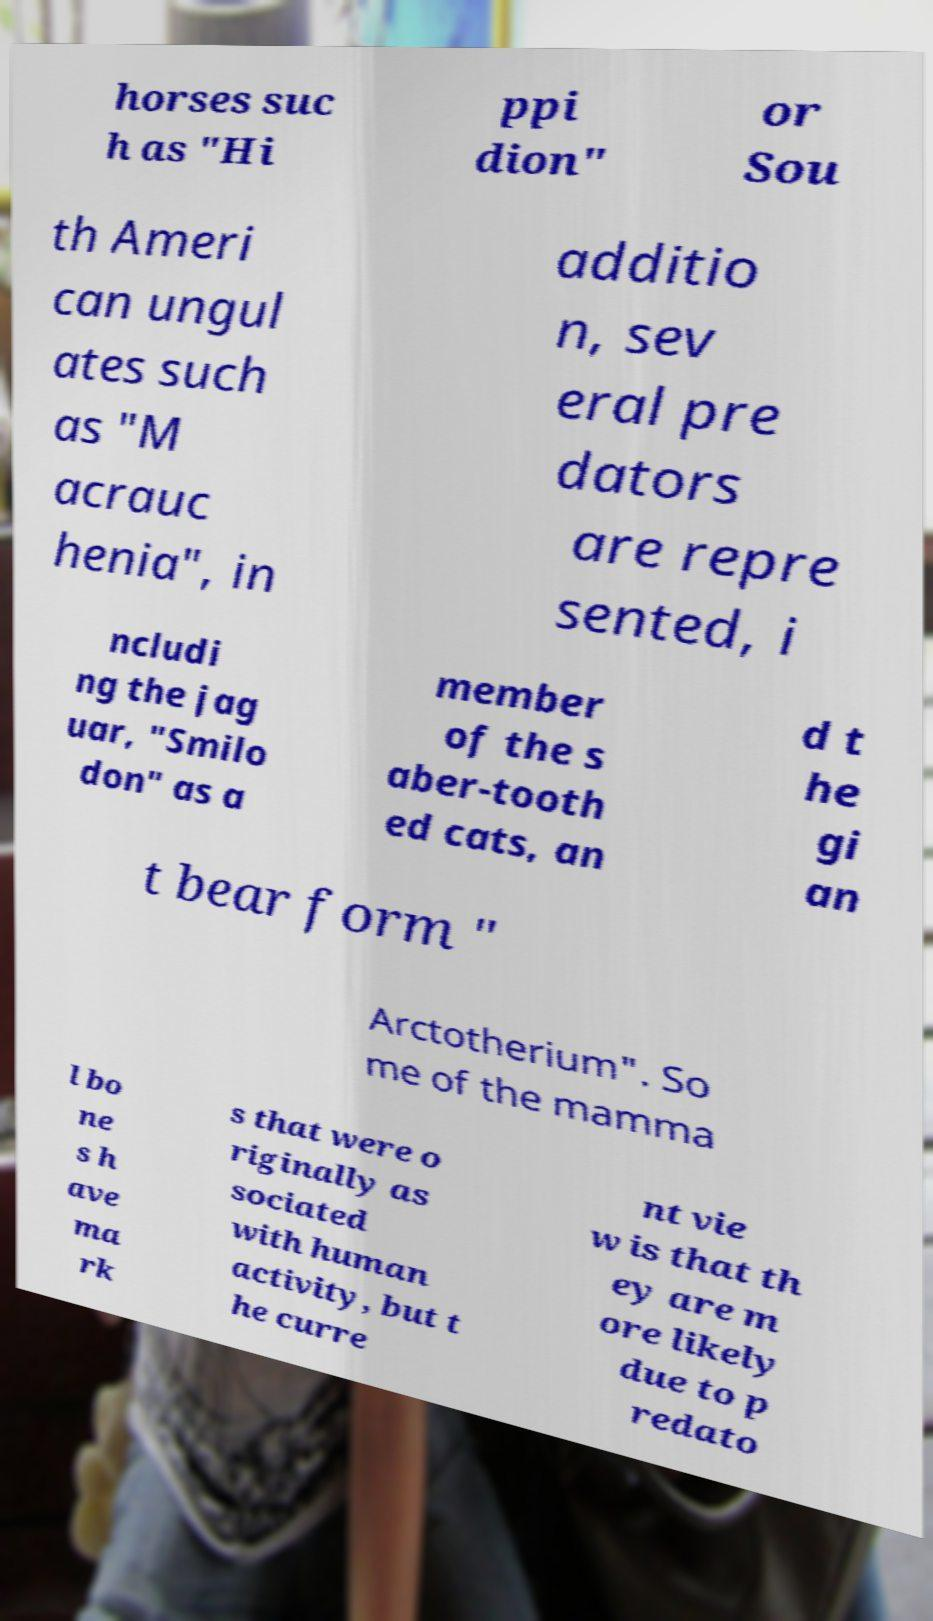What messages or text are displayed in this image? I need them in a readable, typed format. horses suc h as "Hi ppi dion" or Sou th Ameri can ungul ates such as "M acrauc henia", in additio n, sev eral pre dators are repre sented, i ncludi ng the jag uar, "Smilo don" as a member of the s aber-tooth ed cats, an d t he gi an t bear form " Arctotherium". So me of the mamma l bo ne s h ave ma rk s that were o riginally as sociated with human activity, but t he curre nt vie w is that th ey are m ore likely due to p redato 